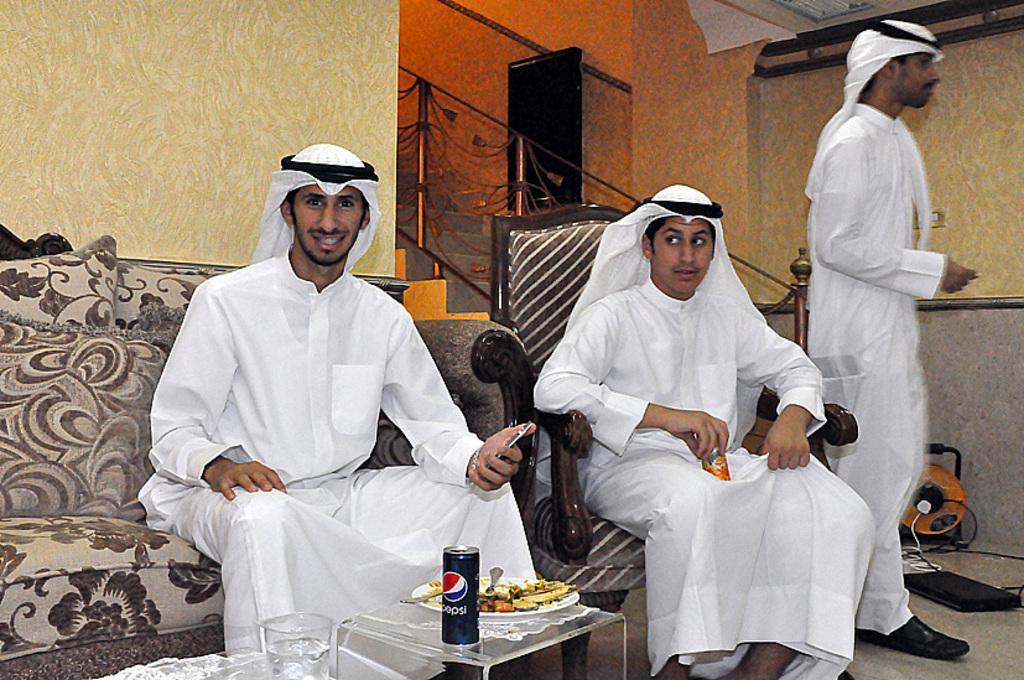In one or two sentences, can you explain what this image depicts? In this picture there is a man who is sitting on the couch and holding a mobile phone. In front of him I can see the coke can, plate, water glass and food items on the table. Beside him I can see another man who is holding a coke can and sitting on the chair. Besides him there is another man who is standing near to the laptop and cables. In the back I can see the stairs and glass railing. 